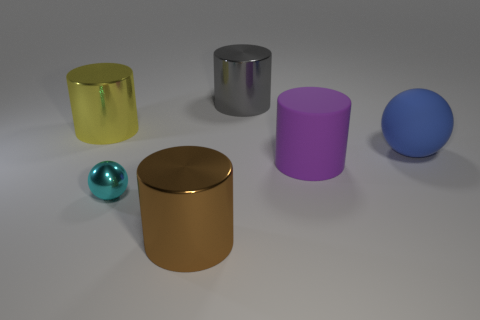Add 3 big metal objects. How many objects exist? 9 Subtract 1 balls. How many balls are left? 1 Subtract all gray metallic cylinders. How many cylinders are left? 3 Subtract all brown cylinders. How many cylinders are left? 3 Subtract all yellow cylinders. How many gray balls are left? 0 Subtract all red rubber spheres. Subtract all brown objects. How many objects are left? 5 Add 2 brown metallic things. How many brown metallic things are left? 3 Add 2 yellow cylinders. How many yellow cylinders exist? 3 Subtract 1 gray cylinders. How many objects are left? 5 Subtract all cylinders. How many objects are left? 2 